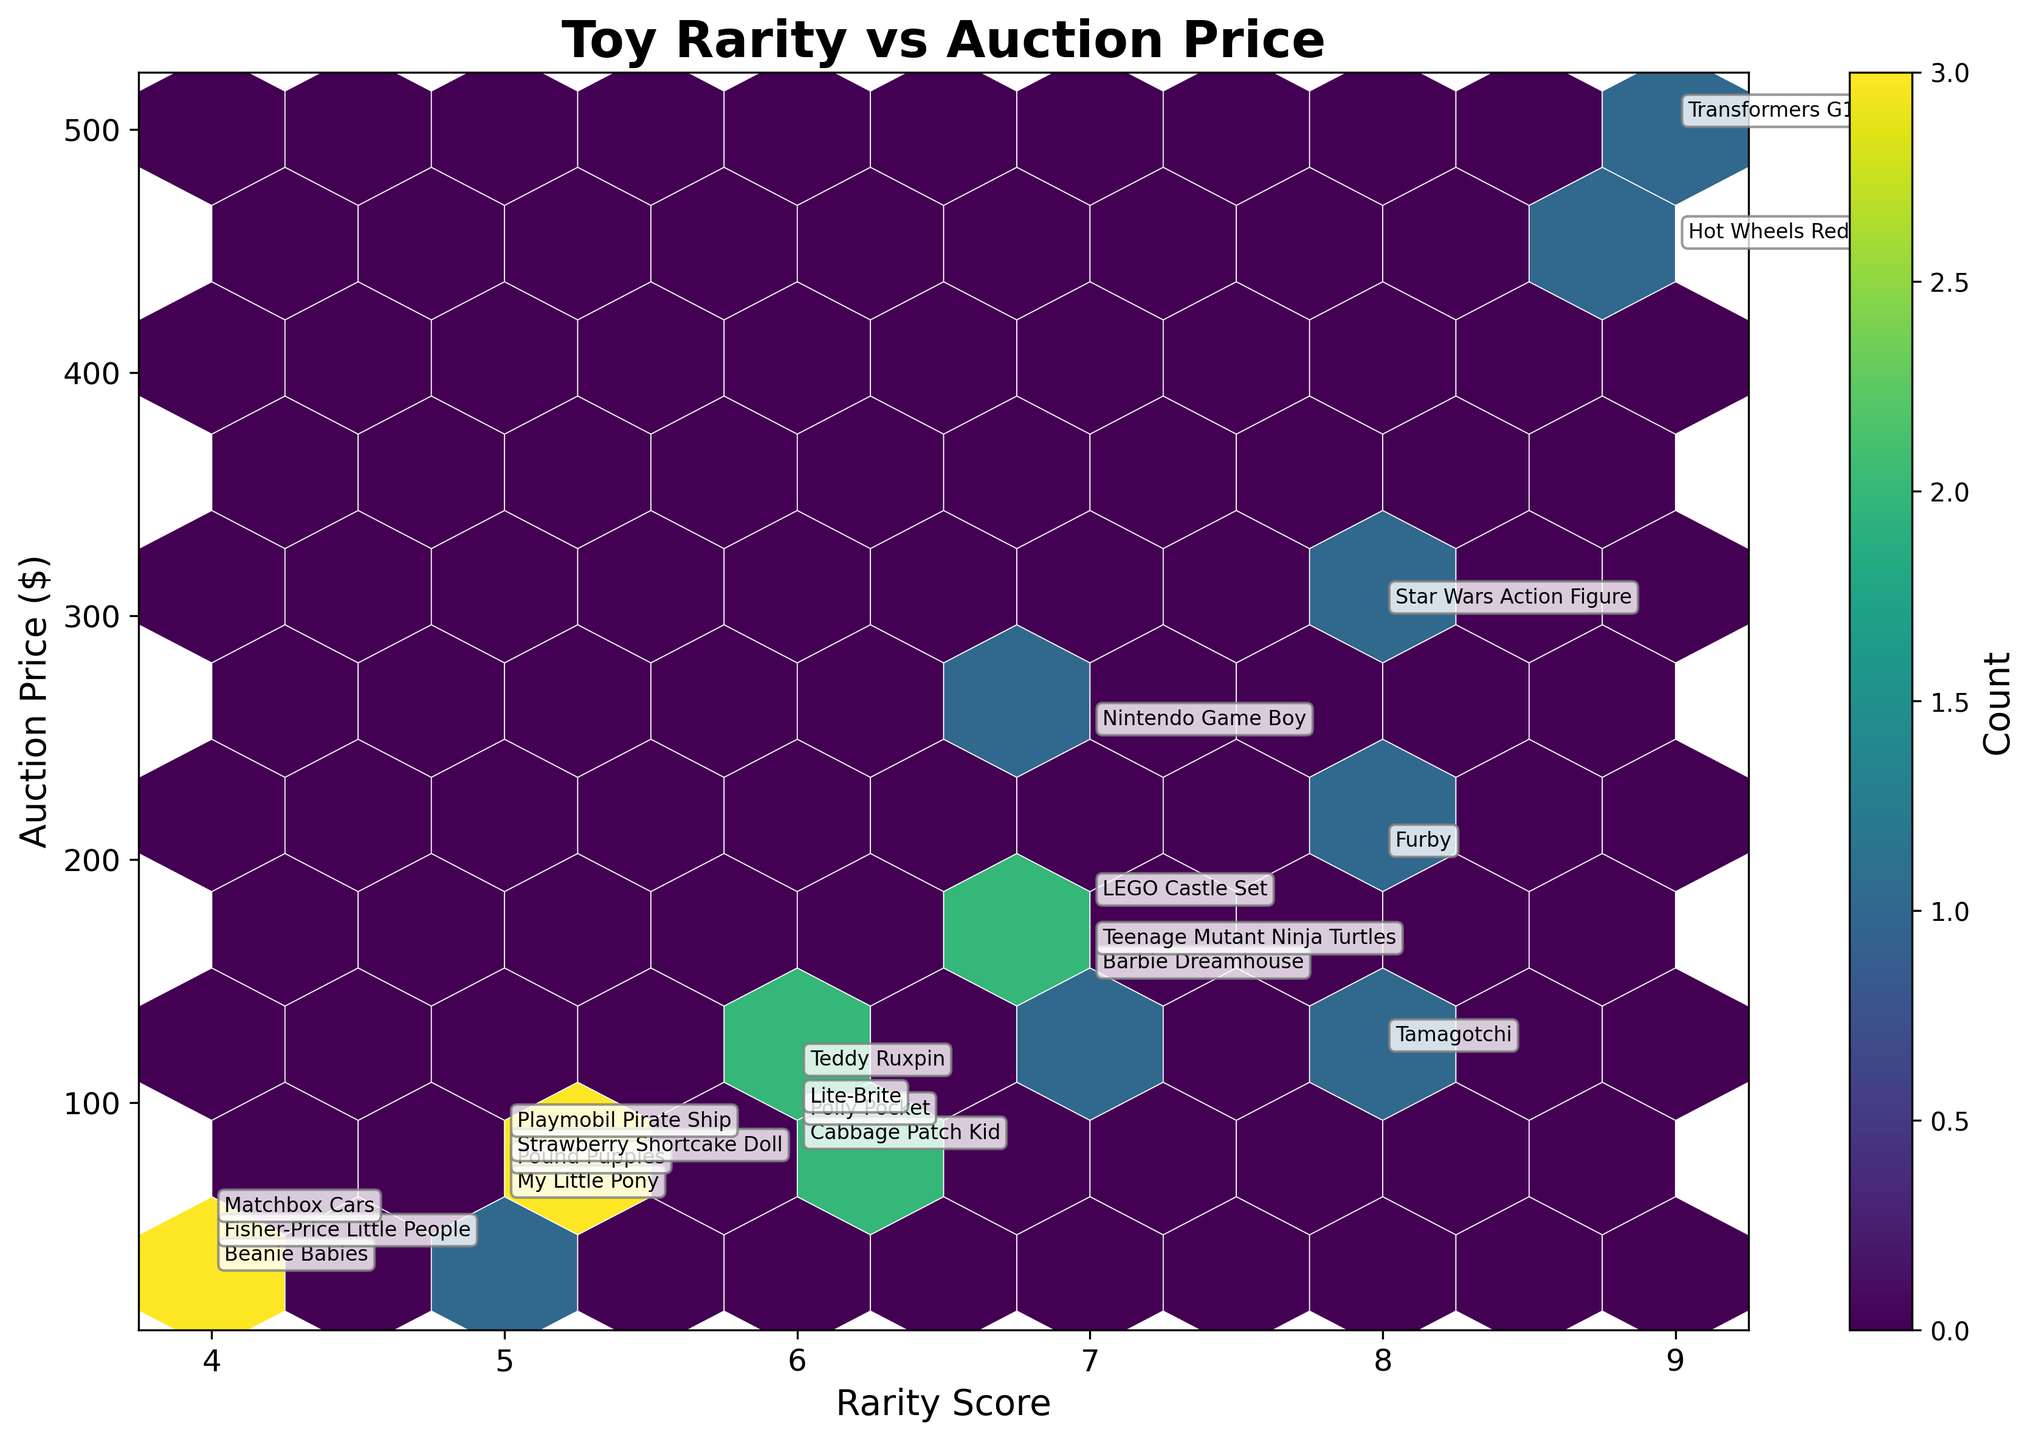How many data points show a high level of auction price and rarity? Let's identify the data clusters with high values. The hexbin plot uses color intensity to show the density of points. Here, the top right corner, representing both high rarity scores and high auction prices, should be reviewed for the densest clusters. Count the visually noticeable data points there.
Answer: 4 Is there any apparent correlation between toy rarity and auction price? Observe the hexbin plot for patterns. A positive correlation would mean that higher rarity scores generally correspond with higher auction prices. Checking if the hexagonal bins trend upwards from left to right suggests a correlation.
Answer: Yes, there is a positive correlation Which toy has the highest auction price? Look at the annotations on the plot. The toy with the highest auction price will be the annotation closest to the highest y-axis value.
Answer: Transformers G1 How many toys have an auction price higher than $200? Identify the hexagons and annotations above the $200 mark on the y-axis. Count the number of unique toys in those hexagons.
Answer: 5 What is the range of the rarity scores shown in the plot? Check the x-axis labels for the minimum and maximum rarity scores displayed.
Answer: 4 to 9 Which toy corresponds to a rarity score of 8 and has the second highest auction price among those with a rarity score of 8? Locate the rarity score of 8 on the x-axis and identify the y-axis values for auction prices. Compare the second highest auction price with the annotations.
Answer: Star Wars Action Figure Do more toys tend to cluster around a specific rarity score? Look for clusters of hexagons along the x-axis. Identify the rarity score(s) with the densest cluster.
Answer: Yes, around score 7 Which toy has the lowest rarity score and what is its auction price? The lowest rarity score can be identified from the x-axis, and the corresponding annotation will give the auction price.
Answer: Fisher-Price Little People, $40 How many toys have an auction price below $100? Observe the segments on the y-axis below the $100 mark and count the annotated toys within these hexagons.
Answer: 6 Is there a toy with a rarity score of 5 that has an auction price higher than $80? Find the rarity score of 5 on the x-axis, then look for hexagons and annotations on the y-axis above the $80 line.
Answer: Yes, Playmobil Pirate Ship 